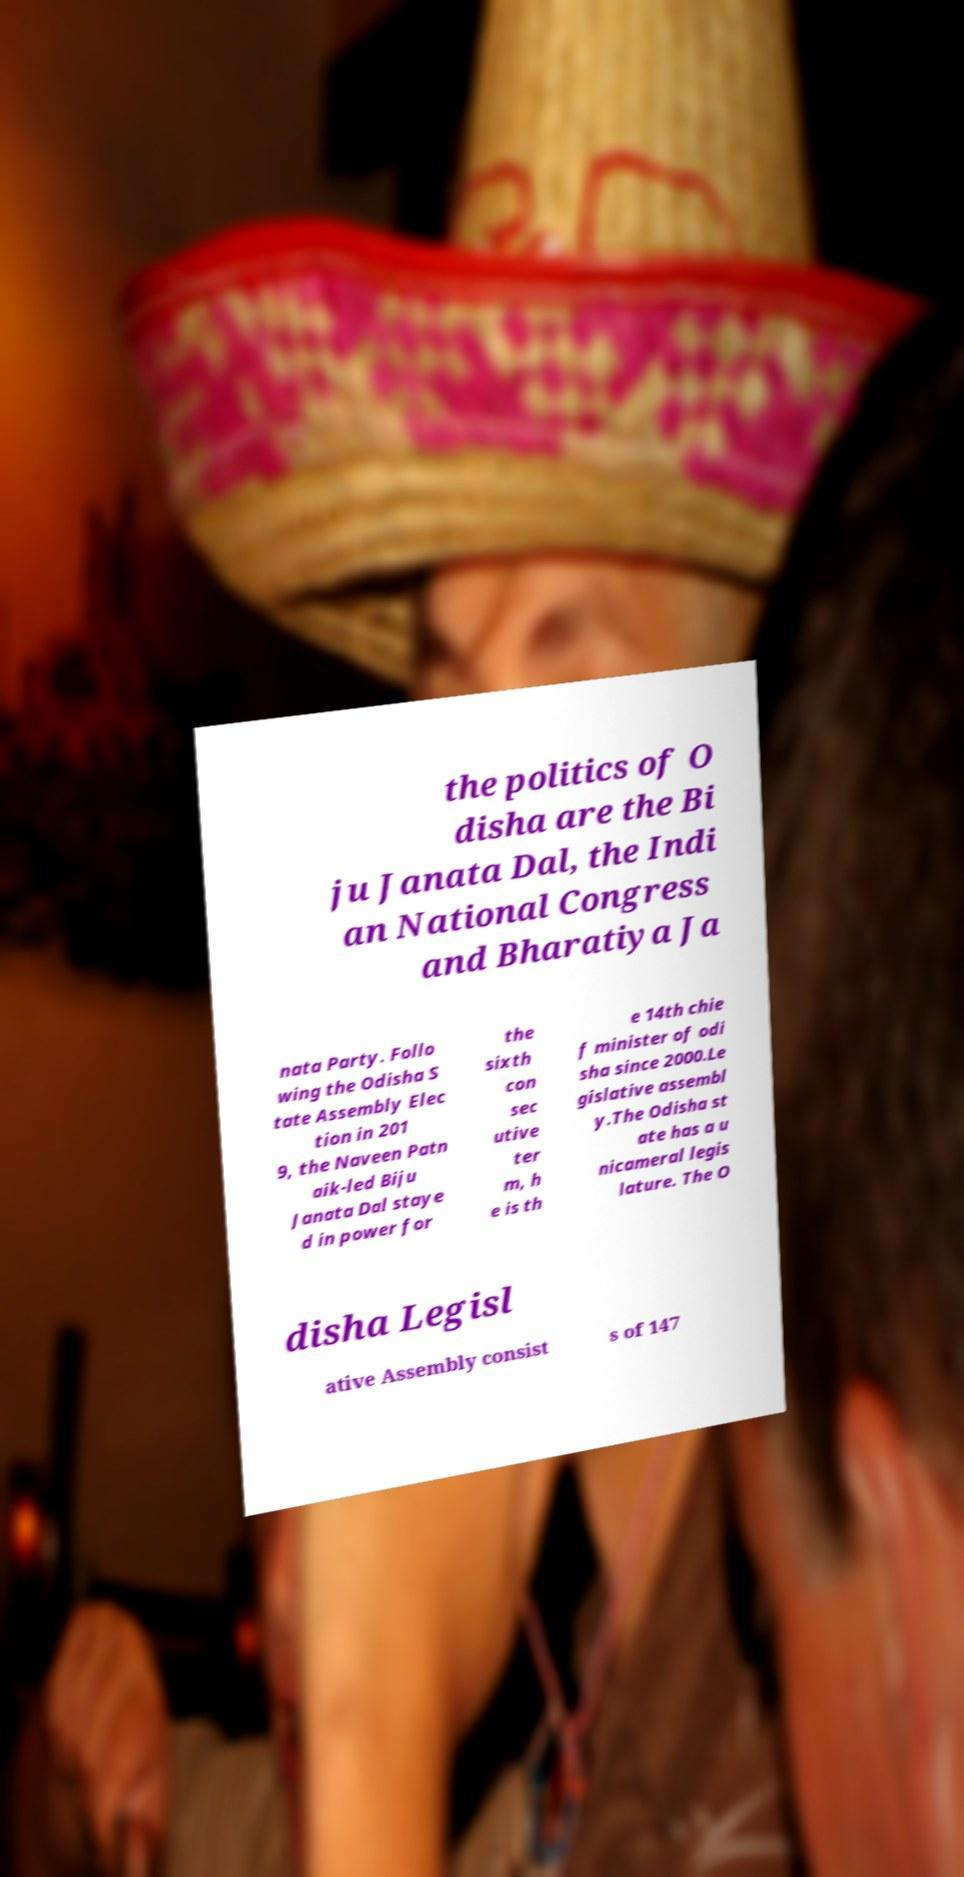Please read and relay the text visible in this image. What does it say? the politics of O disha are the Bi ju Janata Dal, the Indi an National Congress and Bharatiya Ja nata Party. Follo wing the Odisha S tate Assembly Elec tion in 201 9, the Naveen Patn aik-led Biju Janata Dal staye d in power for the sixth con sec utive ter m, h e is th e 14th chie f minister of odi sha since 2000.Le gislative assembl y.The Odisha st ate has a u nicameral legis lature. The O disha Legisl ative Assembly consist s of 147 